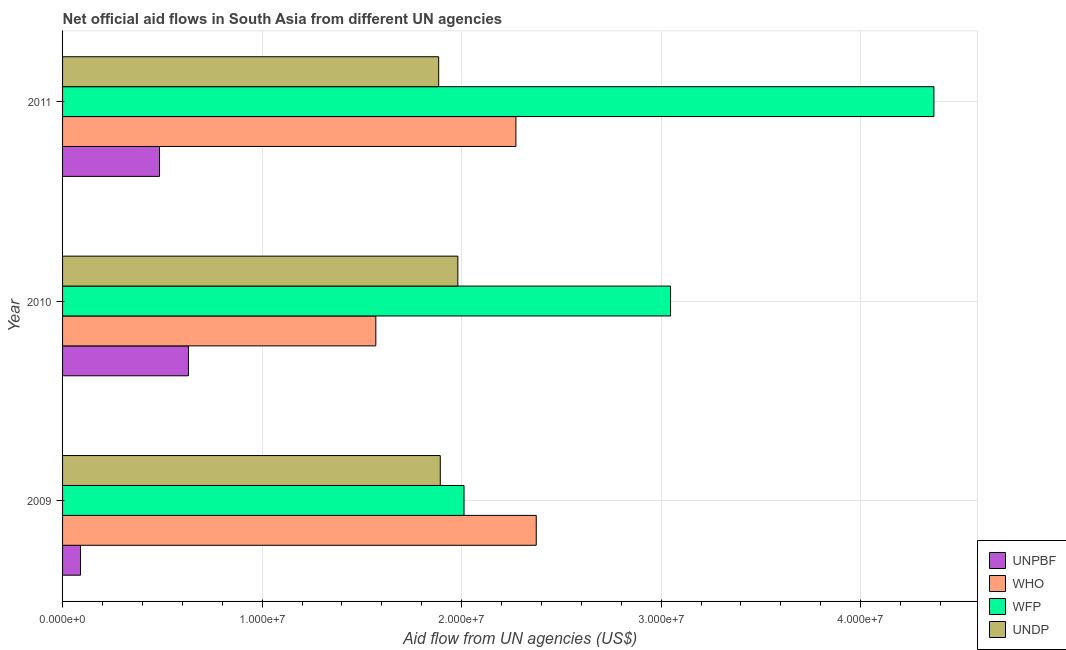How many different coloured bars are there?
Keep it short and to the point. 4. How many groups of bars are there?
Offer a terse response. 3. Are the number of bars per tick equal to the number of legend labels?
Provide a short and direct response. Yes. In how many cases, is the number of bars for a given year not equal to the number of legend labels?
Keep it short and to the point. 0. What is the amount of aid given by who in 2009?
Keep it short and to the point. 2.37e+07. Across all years, what is the maximum amount of aid given by who?
Make the answer very short. 2.37e+07. Across all years, what is the minimum amount of aid given by unpbf?
Your answer should be very brief. 9.00e+05. In which year was the amount of aid given by undp maximum?
Offer a very short reply. 2010. What is the total amount of aid given by unpbf in the graph?
Provide a succinct answer. 1.21e+07. What is the difference between the amount of aid given by unpbf in 2009 and that in 2010?
Offer a terse response. -5.41e+06. What is the difference between the amount of aid given by wfp in 2009 and the amount of aid given by unpbf in 2011?
Provide a succinct answer. 1.53e+07. What is the average amount of aid given by wfp per year?
Make the answer very short. 3.14e+07. In the year 2009, what is the difference between the amount of aid given by who and amount of aid given by wfp?
Your response must be concise. 3.62e+06. In how many years, is the amount of aid given by unpbf greater than 26000000 US$?
Keep it short and to the point. 0. What is the ratio of the amount of aid given by wfp in 2009 to that in 2011?
Make the answer very short. 0.46. Is the amount of aid given by unpbf in 2009 less than that in 2011?
Keep it short and to the point. Yes. What is the difference between the highest and the second highest amount of aid given by wfp?
Give a very brief answer. 1.32e+07. What is the difference between the highest and the lowest amount of aid given by wfp?
Provide a short and direct response. 2.36e+07. In how many years, is the amount of aid given by wfp greater than the average amount of aid given by wfp taken over all years?
Provide a short and direct response. 1. Is the sum of the amount of aid given by who in 2009 and 2010 greater than the maximum amount of aid given by unpbf across all years?
Your answer should be very brief. Yes. What does the 4th bar from the top in 2010 represents?
Keep it short and to the point. UNPBF. What does the 3rd bar from the bottom in 2010 represents?
Offer a terse response. WFP. How many bars are there?
Provide a short and direct response. 12. How many years are there in the graph?
Your response must be concise. 3. What is the difference between two consecutive major ticks on the X-axis?
Provide a short and direct response. 1.00e+07. Are the values on the major ticks of X-axis written in scientific E-notation?
Your response must be concise. Yes. Does the graph contain grids?
Offer a terse response. Yes. How are the legend labels stacked?
Your answer should be compact. Vertical. What is the title of the graph?
Your response must be concise. Net official aid flows in South Asia from different UN agencies. What is the label or title of the X-axis?
Provide a succinct answer. Aid flow from UN agencies (US$). What is the Aid flow from UN agencies (US$) of UNPBF in 2009?
Offer a very short reply. 9.00e+05. What is the Aid flow from UN agencies (US$) of WHO in 2009?
Offer a very short reply. 2.37e+07. What is the Aid flow from UN agencies (US$) in WFP in 2009?
Provide a short and direct response. 2.01e+07. What is the Aid flow from UN agencies (US$) in UNDP in 2009?
Provide a succinct answer. 1.89e+07. What is the Aid flow from UN agencies (US$) in UNPBF in 2010?
Keep it short and to the point. 6.31e+06. What is the Aid flow from UN agencies (US$) of WHO in 2010?
Provide a succinct answer. 1.57e+07. What is the Aid flow from UN agencies (US$) of WFP in 2010?
Make the answer very short. 3.05e+07. What is the Aid flow from UN agencies (US$) in UNDP in 2010?
Offer a terse response. 1.98e+07. What is the Aid flow from UN agencies (US$) of UNPBF in 2011?
Provide a succinct answer. 4.86e+06. What is the Aid flow from UN agencies (US$) of WHO in 2011?
Offer a very short reply. 2.27e+07. What is the Aid flow from UN agencies (US$) of WFP in 2011?
Make the answer very short. 4.37e+07. What is the Aid flow from UN agencies (US$) in UNDP in 2011?
Give a very brief answer. 1.88e+07. Across all years, what is the maximum Aid flow from UN agencies (US$) of UNPBF?
Provide a short and direct response. 6.31e+06. Across all years, what is the maximum Aid flow from UN agencies (US$) in WHO?
Provide a succinct answer. 2.37e+07. Across all years, what is the maximum Aid flow from UN agencies (US$) of WFP?
Provide a short and direct response. 4.37e+07. Across all years, what is the maximum Aid flow from UN agencies (US$) of UNDP?
Offer a terse response. 1.98e+07. Across all years, what is the minimum Aid flow from UN agencies (US$) in WHO?
Your answer should be very brief. 1.57e+07. Across all years, what is the minimum Aid flow from UN agencies (US$) of WFP?
Offer a terse response. 2.01e+07. Across all years, what is the minimum Aid flow from UN agencies (US$) of UNDP?
Your answer should be compact. 1.88e+07. What is the total Aid flow from UN agencies (US$) of UNPBF in the graph?
Keep it short and to the point. 1.21e+07. What is the total Aid flow from UN agencies (US$) of WHO in the graph?
Give a very brief answer. 6.22e+07. What is the total Aid flow from UN agencies (US$) in WFP in the graph?
Provide a succinct answer. 9.43e+07. What is the total Aid flow from UN agencies (US$) of UNDP in the graph?
Keep it short and to the point. 5.76e+07. What is the difference between the Aid flow from UN agencies (US$) of UNPBF in 2009 and that in 2010?
Offer a very short reply. -5.41e+06. What is the difference between the Aid flow from UN agencies (US$) in WHO in 2009 and that in 2010?
Provide a succinct answer. 8.04e+06. What is the difference between the Aid flow from UN agencies (US$) in WFP in 2009 and that in 2010?
Provide a succinct answer. -1.04e+07. What is the difference between the Aid flow from UN agencies (US$) of UNDP in 2009 and that in 2010?
Your answer should be very brief. -8.80e+05. What is the difference between the Aid flow from UN agencies (US$) of UNPBF in 2009 and that in 2011?
Offer a very short reply. -3.96e+06. What is the difference between the Aid flow from UN agencies (US$) in WHO in 2009 and that in 2011?
Your response must be concise. 1.02e+06. What is the difference between the Aid flow from UN agencies (US$) of WFP in 2009 and that in 2011?
Offer a terse response. -2.36e+07. What is the difference between the Aid flow from UN agencies (US$) in UNDP in 2009 and that in 2011?
Provide a short and direct response. 8.00e+04. What is the difference between the Aid flow from UN agencies (US$) of UNPBF in 2010 and that in 2011?
Provide a short and direct response. 1.45e+06. What is the difference between the Aid flow from UN agencies (US$) in WHO in 2010 and that in 2011?
Give a very brief answer. -7.02e+06. What is the difference between the Aid flow from UN agencies (US$) of WFP in 2010 and that in 2011?
Your answer should be very brief. -1.32e+07. What is the difference between the Aid flow from UN agencies (US$) in UNDP in 2010 and that in 2011?
Give a very brief answer. 9.60e+05. What is the difference between the Aid flow from UN agencies (US$) in UNPBF in 2009 and the Aid flow from UN agencies (US$) in WHO in 2010?
Give a very brief answer. -1.48e+07. What is the difference between the Aid flow from UN agencies (US$) of UNPBF in 2009 and the Aid flow from UN agencies (US$) of WFP in 2010?
Offer a terse response. -2.96e+07. What is the difference between the Aid flow from UN agencies (US$) of UNPBF in 2009 and the Aid flow from UN agencies (US$) of UNDP in 2010?
Offer a terse response. -1.89e+07. What is the difference between the Aid flow from UN agencies (US$) of WHO in 2009 and the Aid flow from UN agencies (US$) of WFP in 2010?
Offer a terse response. -6.73e+06. What is the difference between the Aid flow from UN agencies (US$) of WHO in 2009 and the Aid flow from UN agencies (US$) of UNDP in 2010?
Give a very brief answer. 3.93e+06. What is the difference between the Aid flow from UN agencies (US$) of UNPBF in 2009 and the Aid flow from UN agencies (US$) of WHO in 2011?
Give a very brief answer. -2.18e+07. What is the difference between the Aid flow from UN agencies (US$) of UNPBF in 2009 and the Aid flow from UN agencies (US$) of WFP in 2011?
Your answer should be compact. -4.28e+07. What is the difference between the Aid flow from UN agencies (US$) in UNPBF in 2009 and the Aid flow from UN agencies (US$) in UNDP in 2011?
Keep it short and to the point. -1.80e+07. What is the difference between the Aid flow from UN agencies (US$) in WHO in 2009 and the Aid flow from UN agencies (US$) in WFP in 2011?
Your answer should be compact. -1.99e+07. What is the difference between the Aid flow from UN agencies (US$) in WHO in 2009 and the Aid flow from UN agencies (US$) in UNDP in 2011?
Provide a short and direct response. 4.89e+06. What is the difference between the Aid flow from UN agencies (US$) in WFP in 2009 and the Aid flow from UN agencies (US$) in UNDP in 2011?
Make the answer very short. 1.27e+06. What is the difference between the Aid flow from UN agencies (US$) of UNPBF in 2010 and the Aid flow from UN agencies (US$) of WHO in 2011?
Your answer should be compact. -1.64e+07. What is the difference between the Aid flow from UN agencies (US$) of UNPBF in 2010 and the Aid flow from UN agencies (US$) of WFP in 2011?
Keep it short and to the point. -3.74e+07. What is the difference between the Aid flow from UN agencies (US$) in UNPBF in 2010 and the Aid flow from UN agencies (US$) in UNDP in 2011?
Your response must be concise. -1.25e+07. What is the difference between the Aid flow from UN agencies (US$) in WHO in 2010 and the Aid flow from UN agencies (US$) in WFP in 2011?
Your answer should be compact. -2.80e+07. What is the difference between the Aid flow from UN agencies (US$) in WHO in 2010 and the Aid flow from UN agencies (US$) in UNDP in 2011?
Ensure brevity in your answer.  -3.15e+06. What is the difference between the Aid flow from UN agencies (US$) in WFP in 2010 and the Aid flow from UN agencies (US$) in UNDP in 2011?
Provide a short and direct response. 1.16e+07. What is the average Aid flow from UN agencies (US$) of UNPBF per year?
Your answer should be compact. 4.02e+06. What is the average Aid flow from UN agencies (US$) of WHO per year?
Offer a very short reply. 2.07e+07. What is the average Aid flow from UN agencies (US$) of WFP per year?
Offer a terse response. 3.14e+07. What is the average Aid flow from UN agencies (US$) of UNDP per year?
Your response must be concise. 1.92e+07. In the year 2009, what is the difference between the Aid flow from UN agencies (US$) of UNPBF and Aid flow from UN agencies (US$) of WHO?
Provide a succinct answer. -2.28e+07. In the year 2009, what is the difference between the Aid flow from UN agencies (US$) of UNPBF and Aid flow from UN agencies (US$) of WFP?
Provide a short and direct response. -1.92e+07. In the year 2009, what is the difference between the Aid flow from UN agencies (US$) of UNPBF and Aid flow from UN agencies (US$) of UNDP?
Your response must be concise. -1.80e+07. In the year 2009, what is the difference between the Aid flow from UN agencies (US$) in WHO and Aid flow from UN agencies (US$) in WFP?
Make the answer very short. 3.62e+06. In the year 2009, what is the difference between the Aid flow from UN agencies (US$) of WHO and Aid flow from UN agencies (US$) of UNDP?
Keep it short and to the point. 4.81e+06. In the year 2009, what is the difference between the Aid flow from UN agencies (US$) of WFP and Aid flow from UN agencies (US$) of UNDP?
Ensure brevity in your answer.  1.19e+06. In the year 2010, what is the difference between the Aid flow from UN agencies (US$) of UNPBF and Aid flow from UN agencies (US$) of WHO?
Your answer should be very brief. -9.39e+06. In the year 2010, what is the difference between the Aid flow from UN agencies (US$) in UNPBF and Aid flow from UN agencies (US$) in WFP?
Keep it short and to the point. -2.42e+07. In the year 2010, what is the difference between the Aid flow from UN agencies (US$) of UNPBF and Aid flow from UN agencies (US$) of UNDP?
Your response must be concise. -1.35e+07. In the year 2010, what is the difference between the Aid flow from UN agencies (US$) of WHO and Aid flow from UN agencies (US$) of WFP?
Your answer should be very brief. -1.48e+07. In the year 2010, what is the difference between the Aid flow from UN agencies (US$) of WHO and Aid flow from UN agencies (US$) of UNDP?
Provide a succinct answer. -4.11e+06. In the year 2010, what is the difference between the Aid flow from UN agencies (US$) of WFP and Aid flow from UN agencies (US$) of UNDP?
Ensure brevity in your answer.  1.07e+07. In the year 2011, what is the difference between the Aid flow from UN agencies (US$) of UNPBF and Aid flow from UN agencies (US$) of WHO?
Give a very brief answer. -1.79e+07. In the year 2011, what is the difference between the Aid flow from UN agencies (US$) in UNPBF and Aid flow from UN agencies (US$) in WFP?
Your answer should be very brief. -3.88e+07. In the year 2011, what is the difference between the Aid flow from UN agencies (US$) in UNPBF and Aid flow from UN agencies (US$) in UNDP?
Provide a succinct answer. -1.40e+07. In the year 2011, what is the difference between the Aid flow from UN agencies (US$) in WHO and Aid flow from UN agencies (US$) in WFP?
Give a very brief answer. -2.10e+07. In the year 2011, what is the difference between the Aid flow from UN agencies (US$) in WHO and Aid flow from UN agencies (US$) in UNDP?
Keep it short and to the point. 3.87e+06. In the year 2011, what is the difference between the Aid flow from UN agencies (US$) of WFP and Aid flow from UN agencies (US$) of UNDP?
Your response must be concise. 2.48e+07. What is the ratio of the Aid flow from UN agencies (US$) in UNPBF in 2009 to that in 2010?
Your answer should be compact. 0.14. What is the ratio of the Aid flow from UN agencies (US$) of WHO in 2009 to that in 2010?
Offer a terse response. 1.51. What is the ratio of the Aid flow from UN agencies (US$) of WFP in 2009 to that in 2010?
Make the answer very short. 0.66. What is the ratio of the Aid flow from UN agencies (US$) of UNDP in 2009 to that in 2010?
Provide a succinct answer. 0.96. What is the ratio of the Aid flow from UN agencies (US$) of UNPBF in 2009 to that in 2011?
Make the answer very short. 0.19. What is the ratio of the Aid flow from UN agencies (US$) of WHO in 2009 to that in 2011?
Offer a terse response. 1.04. What is the ratio of the Aid flow from UN agencies (US$) of WFP in 2009 to that in 2011?
Provide a succinct answer. 0.46. What is the ratio of the Aid flow from UN agencies (US$) of UNPBF in 2010 to that in 2011?
Offer a very short reply. 1.3. What is the ratio of the Aid flow from UN agencies (US$) of WHO in 2010 to that in 2011?
Your answer should be compact. 0.69. What is the ratio of the Aid flow from UN agencies (US$) of WFP in 2010 to that in 2011?
Your answer should be very brief. 0.7. What is the ratio of the Aid flow from UN agencies (US$) of UNDP in 2010 to that in 2011?
Offer a terse response. 1.05. What is the difference between the highest and the second highest Aid flow from UN agencies (US$) in UNPBF?
Keep it short and to the point. 1.45e+06. What is the difference between the highest and the second highest Aid flow from UN agencies (US$) in WHO?
Make the answer very short. 1.02e+06. What is the difference between the highest and the second highest Aid flow from UN agencies (US$) of WFP?
Your answer should be very brief. 1.32e+07. What is the difference between the highest and the second highest Aid flow from UN agencies (US$) in UNDP?
Provide a succinct answer. 8.80e+05. What is the difference between the highest and the lowest Aid flow from UN agencies (US$) of UNPBF?
Offer a terse response. 5.41e+06. What is the difference between the highest and the lowest Aid flow from UN agencies (US$) in WHO?
Provide a short and direct response. 8.04e+06. What is the difference between the highest and the lowest Aid flow from UN agencies (US$) in WFP?
Your answer should be very brief. 2.36e+07. What is the difference between the highest and the lowest Aid flow from UN agencies (US$) of UNDP?
Give a very brief answer. 9.60e+05. 